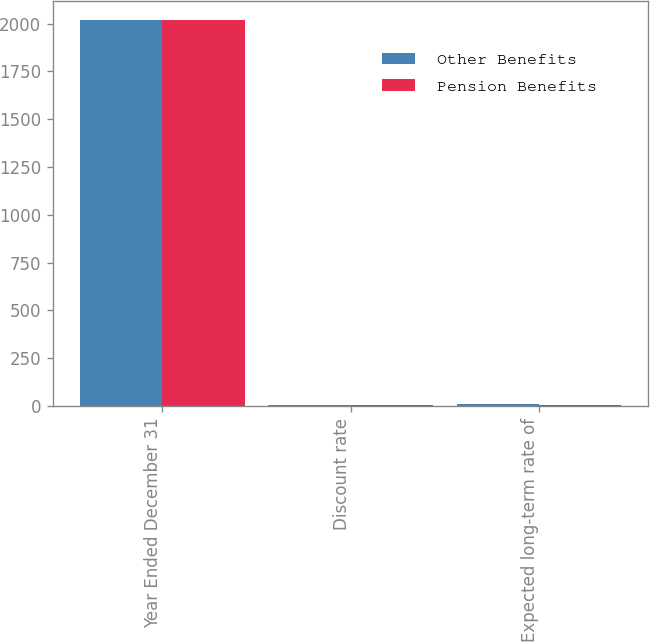Convert chart to OTSL. <chart><loc_0><loc_0><loc_500><loc_500><stacked_bar_chart><ecel><fcel>Year Ended December 31<fcel>Discount rate<fcel>Expected long-term rate of<nl><fcel>Other Benefits<fcel>2018<fcel>3.5<fcel>8<nl><fcel>Pension Benefits<fcel>2018<fcel>3.5<fcel>4.5<nl></chart> 